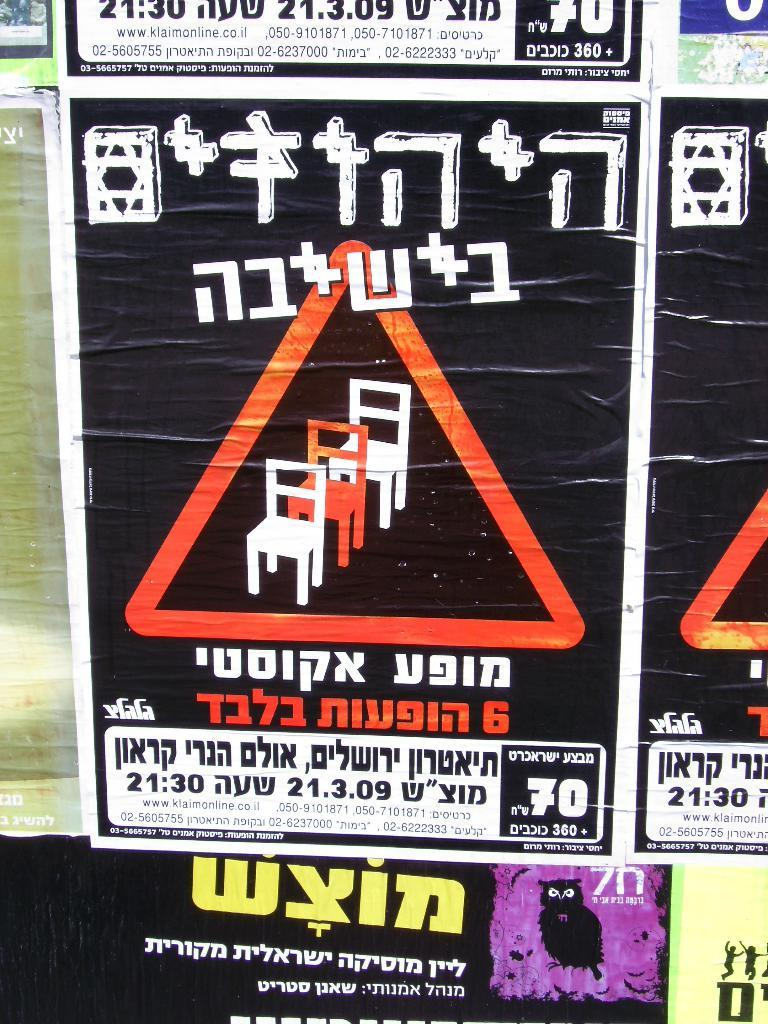What types of items are featured on the wall in the image? There are posters and boards in the image. What color are the posters and boards? The posters and boards are black in color. What can be seen on the posters? There is text written on the posters in different languages. What color is the wall on which the posters are pasted? The posters are pasted on a yellow wall. Can you see a hat in the image? There is no hat present in the image. 